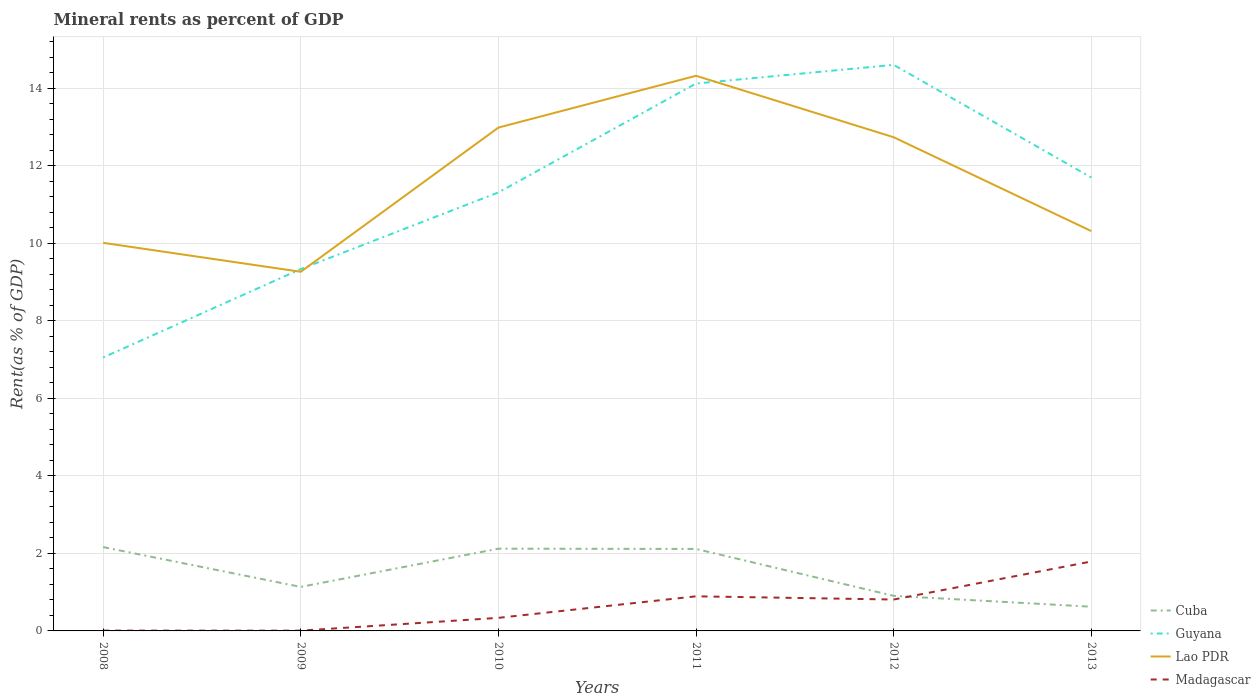How many different coloured lines are there?
Make the answer very short. 4. Is the number of lines equal to the number of legend labels?
Keep it short and to the point. Yes. Across all years, what is the maximum mineral rent in Madagascar?
Your answer should be compact. 0.01. What is the total mineral rent in Cuba in the graph?
Offer a terse response. 1.49. What is the difference between the highest and the second highest mineral rent in Guyana?
Offer a very short reply. 7.55. What is the difference between the highest and the lowest mineral rent in Cuba?
Your answer should be compact. 3. Is the mineral rent in Madagascar strictly greater than the mineral rent in Cuba over the years?
Your response must be concise. No. How many years are there in the graph?
Offer a very short reply. 6. Are the values on the major ticks of Y-axis written in scientific E-notation?
Ensure brevity in your answer.  No. Does the graph contain grids?
Provide a short and direct response. Yes. What is the title of the graph?
Your response must be concise. Mineral rents as percent of GDP. Does "Romania" appear as one of the legend labels in the graph?
Make the answer very short. No. What is the label or title of the Y-axis?
Offer a very short reply. Rent(as % of GDP). What is the Rent(as % of GDP) of Cuba in 2008?
Keep it short and to the point. 2.16. What is the Rent(as % of GDP) in Guyana in 2008?
Make the answer very short. 7.06. What is the Rent(as % of GDP) of Lao PDR in 2008?
Offer a very short reply. 10.02. What is the Rent(as % of GDP) of Madagascar in 2008?
Provide a short and direct response. 0.01. What is the Rent(as % of GDP) of Cuba in 2009?
Your answer should be compact. 1.14. What is the Rent(as % of GDP) of Guyana in 2009?
Your answer should be very brief. 9.34. What is the Rent(as % of GDP) of Lao PDR in 2009?
Your response must be concise. 9.27. What is the Rent(as % of GDP) of Madagascar in 2009?
Provide a short and direct response. 0.01. What is the Rent(as % of GDP) of Cuba in 2010?
Offer a terse response. 2.12. What is the Rent(as % of GDP) in Guyana in 2010?
Ensure brevity in your answer.  11.32. What is the Rent(as % of GDP) of Lao PDR in 2010?
Your answer should be compact. 12.99. What is the Rent(as % of GDP) of Madagascar in 2010?
Your answer should be compact. 0.34. What is the Rent(as % of GDP) in Cuba in 2011?
Give a very brief answer. 2.12. What is the Rent(as % of GDP) of Guyana in 2011?
Make the answer very short. 14.13. What is the Rent(as % of GDP) of Lao PDR in 2011?
Offer a very short reply. 14.33. What is the Rent(as % of GDP) of Madagascar in 2011?
Ensure brevity in your answer.  0.89. What is the Rent(as % of GDP) in Cuba in 2012?
Offer a very short reply. 0.91. What is the Rent(as % of GDP) of Guyana in 2012?
Keep it short and to the point. 14.61. What is the Rent(as % of GDP) in Lao PDR in 2012?
Ensure brevity in your answer.  12.74. What is the Rent(as % of GDP) in Madagascar in 2012?
Keep it short and to the point. 0.81. What is the Rent(as % of GDP) in Cuba in 2013?
Provide a short and direct response. 0.62. What is the Rent(as % of GDP) in Guyana in 2013?
Keep it short and to the point. 11.7. What is the Rent(as % of GDP) of Lao PDR in 2013?
Keep it short and to the point. 10.32. What is the Rent(as % of GDP) in Madagascar in 2013?
Provide a short and direct response. 1.79. Across all years, what is the maximum Rent(as % of GDP) in Cuba?
Keep it short and to the point. 2.16. Across all years, what is the maximum Rent(as % of GDP) in Guyana?
Provide a short and direct response. 14.61. Across all years, what is the maximum Rent(as % of GDP) of Lao PDR?
Offer a very short reply. 14.33. Across all years, what is the maximum Rent(as % of GDP) of Madagascar?
Offer a terse response. 1.79. Across all years, what is the minimum Rent(as % of GDP) of Cuba?
Make the answer very short. 0.62. Across all years, what is the minimum Rent(as % of GDP) of Guyana?
Give a very brief answer. 7.06. Across all years, what is the minimum Rent(as % of GDP) of Lao PDR?
Offer a terse response. 9.27. Across all years, what is the minimum Rent(as % of GDP) of Madagascar?
Provide a succinct answer. 0.01. What is the total Rent(as % of GDP) in Cuba in the graph?
Offer a very short reply. 9.07. What is the total Rent(as % of GDP) in Guyana in the graph?
Offer a terse response. 68.15. What is the total Rent(as % of GDP) of Lao PDR in the graph?
Ensure brevity in your answer.  69.67. What is the total Rent(as % of GDP) in Madagascar in the graph?
Ensure brevity in your answer.  3.85. What is the difference between the Rent(as % of GDP) of Cuba in 2008 and that in 2009?
Make the answer very short. 1.03. What is the difference between the Rent(as % of GDP) of Guyana in 2008 and that in 2009?
Give a very brief answer. -2.28. What is the difference between the Rent(as % of GDP) in Lao PDR in 2008 and that in 2009?
Provide a short and direct response. 0.75. What is the difference between the Rent(as % of GDP) in Madagascar in 2008 and that in 2009?
Your answer should be compact. 0. What is the difference between the Rent(as % of GDP) of Cuba in 2008 and that in 2010?
Provide a short and direct response. 0.04. What is the difference between the Rent(as % of GDP) in Guyana in 2008 and that in 2010?
Provide a short and direct response. -4.26. What is the difference between the Rent(as % of GDP) in Lao PDR in 2008 and that in 2010?
Offer a terse response. -2.97. What is the difference between the Rent(as % of GDP) of Madagascar in 2008 and that in 2010?
Ensure brevity in your answer.  -0.33. What is the difference between the Rent(as % of GDP) of Cuba in 2008 and that in 2011?
Make the answer very short. 0.05. What is the difference between the Rent(as % of GDP) of Guyana in 2008 and that in 2011?
Ensure brevity in your answer.  -7.07. What is the difference between the Rent(as % of GDP) of Lao PDR in 2008 and that in 2011?
Your answer should be very brief. -4.31. What is the difference between the Rent(as % of GDP) in Madagascar in 2008 and that in 2011?
Ensure brevity in your answer.  -0.88. What is the difference between the Rent(as % of GDP) in Cuba in 2008 and that in 2012?
Provide a succinct answer. 1.26. What is the difference between the Rent(as % of GDP) of Guyana in 2008 and that in 2012?
Provide a succinct answer. -7.55. What is the difference between the Rent(as % of GDP) in Lao PDR in 2008 and that in 2012?
Your answer should be very brief. -2.73. What is the difference between the Rent(as % of GDP) in Madagascar in 2008 and that in 2012?
Give a very brief answer. -0.8. What is the difference between the Rent(as % of GDP) in Cuba in 2008 and that in 2013?
Keep it short and to the point. 1.54. What is the difference between the Rent(as % of GDP) of Guyana in 2008 and that in 2013?
Provide a succinct answer. -4.65. What is the difference between the Rent(as % of GDP) of Lao PDR in 2008 and that in 2013?
Your answer should be very brief. -0.3. What is the difference between the Rent(as % of GDP) of Madagascar in 2008 and that in 2013?
Make the answer very short. -1.78. What is the difference between the Rent(as % of GDP) of Cuba in 2009 and that in 2010?
Provide a short and direct response. -0.99. What is the difference between the Rent(as % of GDP) of Guyana in 2009 and that in 2010?
Give a very brief answer. -1.98. What is the difference between the Rent(as % of GDP) in Lao PDR in 2009 and that in 2010?
Your response must be concise. -3.72. What is the difference between the Rent(as % of GDP) in Madagascar in 2009 and that in 2010?
Your response must be concise. -0.33. What is the difference between the Rent(as % of GDP) in Cuba in 2009 and that in 2011?
Offer a very short reply. -0.98. What is the difference between the Rent(as % of GDP) in Guyana in 2009 and that in 2011?
Provide a short and direct response. -4.79. What is the difference between the Rent(as % of GDP) in Lao PDR in 2009 and that in 2011?
Your response must be concise. -5.06. What is the difference between the Rent(as % of GDP) in Madagascar in 2009 and that in 2011?
Your answer should be compact. -0.89. What is the difference between the Rent(as % of GDP) in Cuba in 2009 and that in 2012?
Your answer should be very brief. 0.23. What is the difference between the Rent(as % of GDP) in Guyana in 2009 and that in 2012?
Ensure brevity in your answer.  -5.27. What is the difference between the Rent(as % of GDP) in Lao PDR in 2009 and that in 2012?
Provide a succinct answer. -3.47. What is the difference between the Rent(as % of GDP) of Madagascar in 2009 and that in 2012?
Your response must be concise. -0.8. What is the difference between the Rent(as % of GDP) in Cuba in 2009 and that in 2013?
Your response must be concise. 0.51. What is the difference between the Rent(as % of GDP) of Guyana in 2009 and that in 2013?
Your answer should be compact. -2.36. What is the difference between the Rent(as % of GDP) in Lao PDR in 2009 and that in 2013?
Your response must be concise. -1.05. What is the difference between the Rent(as % of GDP) of Madagascar in 2009 and that in 2013?
Provide a short and direct response. -1.78. What is the difference between the Rent(as % of GDP) in Cuba in 2010 and that in 2011?
Give a very brief answer. 0.01. What is the difference between the Rent(as % of GDP) in Guyana in 2010 and that in 2011?
Ensure brevity in your answer.  -2.81. What is the difference between the Rent(as % of GDP) of Lao PDR in 2010 and that in 2011?
Your answer should be compact. -1.34. What is the difference between the Rent(as % of GDP) in Madagascar in 2010 and that in 2011?
Give a very brief answer. -0.56. What is the difference between the Rent(as % of GDP) of Cuba in 2010 and that in 2012?
Your answer should be compact. 1.22. What is the difference between the Rent(as % of GDP) in Guyana in 2010 and that in 2012?
Offer a very short reply. -3.29. What is the difference between the Rent(as % of GDP) in Lao PDR in 2010 and that in 2012?
Keep it short and to the point. 0.25. What is the difference between the Rent(as % of GDP) of Madagascar in 2010 and that in 2012?
Ensure brevity in your answer.  -0.47. What is the difference between the Rent(as % of GDP) of Cuba in 2010 and that in 2013?
Your answer should be very brief. 1.5. What is the difference between the Rent(as % of GDP) of Guyana in 2010 and that in 2013?
Provide a short and direct response. -0.39. What is the difference between the Rent(as % of GDP) in Lao PDR in 2010 and that in 2013?
Offer a terse response. 2.67. What is the difference between the Rent(as % of GDP) of Madagascar in 2010 and that in 2013?
Make the answer very short. -1.45. What is the difference between the Rent(as % of GDP) in Cuba in 2011 and that in 2012?
Your answer should be compact. 1.21. What is the difference between the Rent(as % of GDP) of Guyana in 2011 and that in 2012?
Your answer should be compact. -0.48. What is the difference between the Rent(as % of GDP) in Lao PDR in 2011 and that in 2012?
Your answer should be compact. 1.59. What is the difference between the Rent(as % of GDP) of Madagascar in 2011 and that in 2012?
Your answer should be compact. 0.08. What is the difference between the Rent(as % of GDP) of Cuba in 2011 and that in 2013?
Make the answer very short. 1.49. What is the difference between the Rent(as % of GDP) in Guyana in 2011 and that in 2013?
Make the answer very short. 2.42. What is the difference between the Rent(as % of GDP) in Lao PDR in 2011 and that in 2013?
Ensure brevity in your answer.  4.01. What is the difference between the Rent(as % of GDP) in Madagascar in 2011 and that in 2013?
Provide a short and direct response. -0.9. What is the difference between the Rent(as % of GDP) of Cuba in 2012 and that in 2013?
Provide a succinct answer. 0.28. What is the difference between the Rent(as % of GDP) of Guyana in 2012 and that in 2013?
Your response must be concise. 2.91. What is the difference between the Rent(as % of GDP) in Lao PDR in 2012 and that in 2013?
Your response must be concise. 2.42. What is the difference between the Rent(as % of GDP) of Madagascar in 2012 and that in 2013?
Your answer should be compact. -0.98. What is the difference between the Rent(as % of GDP) in Cuba in 2008 and the Rent(as % of GDP) in Guyana in 2009?
Your response must be concise. -7.18. What is the difference between the Rent(as % of GDP) in Cuba in 2008 and the Rent(as % of GDP) in Lao PDR in 2009?
Offer a terse response. -7.11. What is the difference between the Rent(as % of GDP) of Cuba in 2008 and the Rent(as % of GDP) of Madagascar in 2009?
Your answer should be very brief. 2.16. What is the difference between the Rent(as % of GDP) of Guyana in 2008 and the Rent(as % of GDP) of Lao PDR in 2009?
Offer a very short reply. -2.21. What is the difference between the Rent(as % of GDP) of Guyana in 2008 and the Rent(as % of GDP) of Madagascar in 2009?
Your answer should be very brief. 7.05. What is the difference between the Rent(as % of GDP) in Lao PDR in 2008 and the Rent(as % of GDP) in Madagascar in 2009?
Your response must be concise. 10.01. What is the difference between the Rent(as % of GDP) in Cuba in 2008 and the Rent(as % of GDP) in Guyana in 2010?
Offer a terse response. -9.15. What is the difference between the Rent(as % of GDP) of Cuba in 2008 and the Rent(as % of GDP) of Lao PDR in 2010?
Offer a very short reply. -10.83. What is the difference between the Rent(as % of GDP) in Cuba in 2008 and the Rent(as % of GDP) in Madagascar in 2010?
Offer a terse response. 1.83. What is the difference between the Rent(as % of GDP) of Guyana in 2008 and the Rent(as % of GDP) of Lao PDR in 2010?
Provide a short and direct response. -5.93. What is the difference between the Rent(as % of GDP) in Guyana in 2008 and the Rent(as % of GDP) in Madagascar in 2010?
Give a very brief answer. 6.72. What is the difference between the Rent(as % of GDP) in Lao PDR in 2008 and the Rent(as % of GDP) in Madagascar in 2010?
Your answer should be compact. 9.68. What is the difference between the Rent(as % of GDP) in Cuba in 2008 and the Rent(as % of GDP) in Guyana in 2011?
Provide a short and direct response. -11.96. What is the difference between the Rent(as % of GDP) of Cuba in 2008 and the Rent(as % of GDP) of Lao PDR in 2011?
Give a very brief answer. -12.16. What is the difference between the Rent(as % of GDP) of Cuba in 2008 and the Rent(as % of GDP) of Madagascar in 2011?
Provide a short and direct response. 1.27. What is the difference between the Rent(as % of GDP) in Guyana in 2008 and the Rent(as % of GDP) in Lao PDR in 2011?
Offer a terse response. -7.27. What is the difference between the Rent(as % of GDP) of Guyana in 2008 and the Rent(as % of GDP) of Madagascar in 2011?
Your answer should be compact. 6.16. What is the difference between the Rent(as % of GDP) of Lao PDR in 2008 and the Rent(as % of GDP) of Madagascar in 2011?
Give a very brief answer. 9.12. What is the difference between the Rent(as % of GDP) in Cuba in 2008 and the Rent(as % of GDP) in Guyana in 2012?
Your response must be concise. -12.45. What is the difference between the Rent(as % of GDP) in Cuba in 2008 and the Rent(as % of GDP) in Lao PDR in 2012?
Your response must be concise. -10.58. What is the difference between the Rent(as % of GDP) in Cuba in 2008 and the Rent(as % of GDP) in Madagascar in 2012?
Offer a terse response. 1.35. What is the difference between the Rent(as % of GDP) in Guyana in 2008 and the Rent(as % of GDP) in Lao PDR in 2012?
Your answer should be compact. -5.69. What is the difference between the Rent(as % of GDP) in Guyana in 2008 and the Rent(as % of GDP) in Madagascar in 2012?
Provide a succinct answer. 6.25. What is the difference between the Rent(as % of GDP) in Lao PDR in 2008 and the Rent(as % of GDP) in Madagascar in 2012?
Provide a succinct answer. 9.21. What is the difference between the Rent(as % of GDP) of Cuba in 2008 and the Rent(as % of GDP) of Guyana in 2013?
Your answer should be compact. -9.54. What is the difference between the Rent(as % of GDP) of Cuba in 2008 and the Rent(as % of GDP) of Lao PDR in 2013?
Keep it short and to the point. -8.16. What is the difference between the Rent(as % of GDP) of Cuba in 2008 and the Rent(as % of GDP) of Madagascar in 2013?
Offer a terse response. 0.37. What is the difference between the Rent(as % of GDP) in Guyana in 2008 and the Rent(as % of GDP) in Lao PDR in 2013?
Offer a terse response. -3.26. What is the difference between the Rent(as % of GDP) in Guyana in 2008 and the Rent(as % of GDP) in Madagascar in 2013?
Your response must be concise. 5.26. What is the difference between the Rent(as % of GDP) in Lao PDR in 2008 and the Rent(as % of GDP) in Madagascar in 2013?
Give a very brief answer. 8.23. What is the difference between the Rent(as % of GDP) in Cuba in 2009 and the Rent(as % of GDP) in Guyana in 2010?
Give a very brief answer. -10.18. What is the difference between the Rent(as % of GDP) of Cuba in 2009 and the Rent(as % of GDP) of Lao PDR in 2010?
Make the answer very short. -11.85. What is the difference between the Rent(as % of GDP) of Cuba in 2009 and the Rent(as % of GDP) of Madagascar in 2010?
Offer a very short reply. 0.8. What is the difference between the Rent(as % of GDP) in Guyana in 2009 and the Rent(as % of GDP) in Lao PDR in 2010?
Make the answer very short. -3.65. What is the difference between the Rent(as % of GDP) of Guyana in 2009 and the Rent(as % of GDP) of Madagascar in 2010?
Offer a terse response. 9. What is the difference between the Rent(as % of GDP) in Lao PDR in 2009 and the Rent(as % of GDP) in Madagascar in 2010?
Your response must be concise. 8.93. What is the difference between the Rent(as % of GDP) in Cuba in 2009 and the Rent(as % of GDP) in Guyana in 2011?
Your response must be concise. -12.99. What is the difference between the Rent(as % of GDP) in Cuba in 2009 and the Rent(as % of GDP) in Lao PDR in 2011?
Your answer should be compact. -13.19. What is the difference between the Rent(as % of GDP) in Cuba in 2009 and the Rent(as % of GDP) in Madagascar in 2011?
Give a very brief answer. 0.24. What is the difference between the Rent(as % of GDP) in Guyana in 2009 and the Rent(as % of GDP) in Lao PDR in 2011?
Provide a short and direct response. -4.99. What is the difference between the Rent(as % of GDP) of Guyana in 2009 and the Rent(as % of GDP) of Madagascar in 2011?
Ensure brevity in your answer.  8.45. What is the difference between the Rent(as % of GDP) in Lao PDR in 2009 and the Rent(as % of GDP) in Madagascar in 2011?
Offer a very short reply. 8.38. What is the difference between the Rent(as % of GDP) of Cuba in 2009 and the Rent(as % of GDP) of Guyana in 2012?
Provide a succinct answer. -13.47. What is the difference between the Rent(as % of GDP) of Cuba in 2009 and the Rent(as % of GDP) of Lao PDR in 2012?
Offer a very short reply. -11.61. What is the difference between the Rent(as % of GDP) of Cuba in 2009 and the Rent(as % of GDP) of Madagascar in 2012?
Provide a succinct answer. 0.33. What is the difference between the Rent(as % of GDP) in Guyana in 2009 and the Rent(as % of GDP) in Lao PDR in 2012?
Offer a very short reply. -3.4. What is the difference between the Rent(as % of GDP) of Guyana in 2009 and the Rent(as % of GDP) of Madagascar in 2012?
Ensure brevity in your answer.  8.53. What is the difference between the Rent(as % of GDP) of Lao PDR in 2009 and the Rent(as % of GDP) of Madagascar in 2012?
Ensure brevity in your answer.  8.46. What is the difference between the Rent(as % of GDP) of Cuba in 2009 and the Rent(as % of GDP) of Guyana in 2013?
Ensure brevity in your answer.  -10.57. What is the difference between the Rent(as % of GDP) of Cuba in 2009 and the Rent(as % of GDP) of Lao PDR in 2013?
Make the answer very short. -9.18. What is the difference between the Rent(as % of GDP) of Cuba in 2009 and the Rent(as % of GDP) of Madagascar in 2013?
Your answer should be compact. -0.66. What is the difference between the Rent(as % of GDP) of Guyana in 2009 and the Rent(as % of GDP) of Lao PDR in 2013?
Your answer should be compact. -0.98. What is the difference between the Rent(as % of GDP) of Guyana in 2009 and the Rent(as % of GDP) of Madagascar in 2013?
Make the answer very short. 7.55. What is the difference between the Rent(as % of GDP) of Lao PDR in 2009 and the Rent(as % of GDP) of Madagascar in 2013?
Your answer should be compact. 7.48. What is the difference between the Rent(as % of GDP) in Cuba in 2010 and the Rent(as % of GDP) in Guyana in 2011?
Provide a succinct answer. -12.01. What is the difference between the Rent(as % of GDP) of Cuba in 2010 and the Rent(as % of GDP) of Lao PDR in 2011?
Provide a short and direct response. -12.21. What is the difference between the Rent(as % of GDP) of Cuba in 2010 and the Rent(as % of GDP) of Madagascar in 2011?
Give a very brief answer. 1.23. What is the difference between the Rent(as % of GDP) in Guyana in 2010 and the Rent(as % of GDP) in Lao PDR in 2011?
Keep it short and to the point. -3.01. What is the difference between the Rent(as % of GDP) in Guyana in 2010 and the Rent(as % of GDP) in Madagascar in 2011?
Provide a succinct answer. 10.42. What is the difference between the Rent(as % of GDP) in Lao PDR in 2010 and the Rent(as % of GDP) in Madagascar in 2011?
Offer a very short reply. 12.1. What is the difference between the Rent(as % of GDP) in Cuba in 2010 and the Rent(as % of GDP) in Guyana in 2012?
Make the answer very short. -12.49. What is the difference between the Rent(as % of GDP) of Cuba in 2010 and the Rent(as % of GDP) of Lao PDR in 2012?
Your answer should be very brief. -10.62. What is the difference between the Rent(as % of GDP) of Cuba in 2010 and the Rent(as % of GDP) of Madagascar in 2012?
Provide a short and direct response. 1.31. What is the difference between the Rent(as % of GDP) of Guyana in 2010 and the Rent(as % of GDP) of Lao PDR in 2012?
Your response must be concise. -1.42. What is the difference between the Rent(as % of GDP) of Guyana in 2010 and the Rent(as % of GDP) of Madagascar in 2012?
Your answer should be compact. 10.51. What is the difference between the Rent(as % of GDP) of Lao PDR in 2010 and the Rent(as % of GDP) of Madagascar in 2012?
Your response must be concise. 12.18. What is the difference between the Rent(as % of GDP) in Cuba in 2010 and the Rent(as % of GDP) in Guyana in 2013?
Your answer should be very brief. -9.58. What is the difference between the Rent(as % of GDP) of Cuba in 2010 and the Rent(as % of GDP) of Lao PDR in 2013?
Offer a terse response. -8.2. What is the difference between the Rent(as % of GDP) of Cuba in 2010 and the Rent(as % of GDP) of Madagascar in 2013?
Ensure brevity in your answer.  0.33. What is the difference between the Rent(as % of GDP) of Guyana in 2010 and the Rent(as % of GDP) of Lao PDR in 2013?
Your answer should be very brief. 1. What is the difference between the Rent(as % of GDP) of Guyana in 2010 and the Rent(as % of GDP) of Madagascar in 2013?
Offer a very short reply. 9.53. What is the difference between the Rent(as % of GDP) in Lao PDR in 2010 and the Rent(as % of GDP) in Madagascar in 2013?
Provide a short and direct response. 11.2. What is the difference between the Rent(as % of GDP) in Cuba in 2011 and the Rent(as % of GDP) in Guyana in 2012?
Ensure brevity in your answer.  -12.49. What is the difference between the Rent(as % of GDP) of Cuba in 2011 and the Rent(as % of GDP) of Lao PDR in 2012?
Ensure brevity in your answer.  -10.63. What is the difference between the Rent(as % of GDP) of Cuba in 2011 and the Rent(as % of GDP) of Madagascar in 2012?
Your response must be concise. 1.31. What is the difference between the Rent(as % of GDP) of Guyana in 2011 and the Rent(as % of GDP) of Lao PDR in 2012?
Provide a short and direct response. 1.39. What is the difference between the Rent(as % of GDP) in Guyana in 2011 and the Rent(as % of GDP) in Madagascar in 2012?
Give a very brief answer. 13.32. What is the difference between the Rent(as % of GDP) of Lao PDR in 2011 and the Rent(as % of GDP) of Madagascar in 2012?
Provide a short and direct response. 13.52. What is the difference between the Rent(as % of GDP) of Cuba in 2011 and the Rent(as % of GDP) of Guyana in 2013?
Your answer should be very brief. -9.59. What is the difference between the Rent(as % of GDP) of Cuba in 2011 and the Rent(as % of GDP) of Lao PDR in 2013?
Ensure brevity in your answer.  -8.2. What is the difference between the Rent(as % of GDP) in Cuba in 2011 and the Rent(as % of GDP) in Madagascar in 2013?
Your response must be concise. 0.32. What is the difference between the Rent(as % of GDP) in Guyana in 2011 and the Rent(as % of GDP) in Lao PDR in 2013?
Your answer should be very brief. 3.81. What is the difference between the Rent(as % of GDP) of Guyana in 2011 and the Rent(as % of GDP) of Madagascar in 2013?
Your answer should be very brief. 12.34. What is the difference between the Rent(as % of GDP) in Lao PDR in 2011 and the Rent(as % of GDP) in Madagascar in 2013?
Make the answer very short. 12.54. What is the difference between the Rent(as % of GDP) in Cuba in 2012 and the Rent(as % of GDP) in Guyana in 2013?
Offer a very short reply. -10.8. What is the difference between the Rent(as % of GDP) of Cuba in 2012 and the Rent(as % of GDP) of Lao PDR in 2013?
Provide a short and direct response. -9.41. What is the difference between the Rent(as % of GDP) in Cuba in 2012 and the Rent(as % of GDP) in Madagascar in 2013?
Give a very brief answer. -0.89. What is the difference between the Rent(as % of GDP) in Guyana in 2012 and the Rent(as % of GDP) in Lao PDR in 2013?
Your response must be concise. 4.29. What is the difference between the Rent(as % of GDP) in Guyana in 2012 and the Rent(as % of GDP) in Madagascar in 2013?
Offer a terse response. 12.82. What is the difference between the Rent(as % of GDP) of Lao PDR in 2012 and the Rent(as % of GDP) of Madagascar in 2013?
Give a very brief answer. 10.95. What is the average Rent(as % of GDP) in Cuba per year?
Ensure brevity in your answer.  1.51. What is the average Rent(as % of GDP) in Guyana per year?
Provide a short and direct response. 11.36. What is the average Rent(as % of GDP) in Lao PDR per year?
Offer a very short reply. 11.61. What is the average Rent(as % of GDP) of Madagascar per year?
Your answer should be very brief. 0.64. In the year 2008, what is the difference between the Rent(as % of GDP) in Cuba and Rent(as % of GDP) in Guyana?
Offer a terse response. -4.89. In the year 2008, what is the difference between the Rent(as % of GDP) of Cuba and Rent(as % of GDP) of Lao PDR?
Offer a terse response. -7.85. In the year 2008, what is the difference between the Rent(as % of GDP) of Cuba and Rent(as % of GDP) of Madagascar?
Provide a short and direct response. 2.16. In the year 2008, what is the difference between the Rent(as % of GDP) in Guyana and Rent(as % of GDP) in Lao PDR?
Ensure brevity in your answer.  -2.96. In the year 2008, what is the difference between the Rent(as % of GDP) of Guyana and Rent(as % of GDP) of Madagascar?
Provide a succinct answer. 7.05. In the year 2008, what is the difference between the Rent(as % of GDP) in Lao PDR and Rent(as % of GDP) in Madagascar?
Provide a succinct answer. 10.01. In the year 2009, what is the difference between the Rent(as % of GDP) of Cuba and Rent(as % of GDP) of Guyana?
Ensure brevity in your answer.  -8.2. In the year 2009, what is the difference between the Rent(as % of GDP) of Cuba and Rent(as % of GDP) of Lao PDR?
Offer a very short reply. -8.13. In the year 2009, what is the difference between the Rent(as % of GDP) of Cuba and Rent(as % of GDP) of Madagascar?
Offer a terse response. 1.13. In the year 2009, what is the difference between the Rent(as % of GDP) of Guyana and Rent(as % of GDP) of Lao PDR?
Your answer should be compact. 0.07. In the year 2009, what is the difference between the Rent(as % of GDP) in Guyana and Rent(as % of GDP) in Madagascar?
Your answer should be compact. 9.33. In the year 2009, what is the difference between the Rent(as % of GDP) in Lao PDR and Rent(as % of GDP) in Madagascar?
Ensure brevity in your answer.  9.26. In the year 2010, what is the difference between the Rent(as % of GDP) of Cuba and Rent(as % of GDP) of Guyana?
Provide a short and direct response. -9.2. In the year 2010, what is the difference between the Rent(as % of GDP) of Cuba and Rent(as % of GDP) of Lao PDR?
Provide a succinct answer. -10.87. In the year 2010, what is the difference between the Rent(as % of GDP) of Cuba and Rent(as % of GDP) of Madagascar?
Keep it short and to the point. 1.78. In the year 2010, what is the difference between the Rent(as % of GDP) in Guyana and Rent(as % of GDP) in Lao PDR?
Your answer should be very brief. -1.67. In the year 2010, what is the difference between the Rent(as % of GDP) in Guyana and Rent(as % of GDP) in Madagascar?
Offer a terse response. 10.98. In the year 2010, what is the difference between the Rent(as % of GDP) of Lao PDR and Rent(as % of GDP) of Madagascar?
Your answer should be compact. 12.65. In the year 2011, what is the difference between the Rent(as % of GDP) in Cuba and Rent(as % of GDP) in Guyana?
Offer a terse response. -12.01. In the year 2011, what is the difference between the Rent(as % of GDP) in Cuba and Rent(as % of GDP) in Lao PDR?
Provide a short and direct response. -12.21. In the year 2011, what is the difference between the Rent(as % of GDP) in Cuba and Rent(as % of GDP) in Madagascar?
Keep it short and to the point. 1.22. In the year 2011, what is the difference between the Rent(as % of GDP) in Guyana and Rent(as % of GDP) in Lao PDR?
Offer a very short reply. -0.2. In the year 2011, what is the difference between the Rent(as % of GDP) of Guyana and Rent(as % of GDP) of Madagascar?
Offer a terse response. 13.23. In the year 2011, what is the difference between the Rent(as % of GDP) of Lao PDR and Rent(as % of GDP) of Madagascar?
Ensure brevity in your answer.  13.43. In the year 2012, what is the difference between the Rent(as % of GDP) of Cuba and Rent(as % of GDP) of Guyana?
Your answer should be very brief. -13.7. In the year 2012, what is the difference between the Rent(as % of GDP) in Cuba and Rent(as % of GDP) in Lao PDR?
Offer a very short reply. -11.84. In the year 2012, what is the difference between the Rent(as % of GDP) of Cuba and Rent(as % of GDP) of Madagascar?
Offer a terse response. 0.09. In the year 2012, what is the difference between the Rent(as % of GDP) of Guyana and Rent(as % of GDP) of Lao PDR?
Ensure brevity in your answer.  1.87. In the year 2012, what is the difference between the Rent(as % of GDP) of Guyana and Rent(as % of GDP) of Madagascar?
Your response must be concise. 13.8. In the year 2012, what is the difference between the Rent(as % of GDP) of Lao PDR and Rent(as % of GDP) of Madagascar?
Provide a succinct answer. 11.93. In the year 2013, what is the difference between the Rent(as % of GDP) in Cuba and Rent(as % of GDP) in Guyana?
Provide a short and direct response. -11.08. In the year 2013, what is the difference between the Rent(as % of GDP) of Cuba and Rent(as % of GDP) of Lao PDR?
Give a very brief answer. -9.69. In the year 2013, what is the difference between the Rent(as % of GDP) in Cuba and Rent(as % of GDP) in Madagascar?
Your answer should be very brief. -1.17. In the year 2013, what is the difference between the Rent(as % of GDP) of Guyana and Rent(as % of GDP) of Lao PDR?
Your answer should be very brief. 1.38. In the year 2013, what is the difference between the Rent(as % of GDP) of Guyana and Rent(as % of GDP) of Madagascar?
Ensure brevity in your answer.  9.91. In the year 2013, what is the difference between the Rent(as % of GDP) of Lao PDR and Rent(as % of GDP) of Madagascar?
Your answer should be compact. 8.53. What is the ratio of the Rent(as % of GDP) in Cuba in 2008 to that in 2009?
Offer a very short reply. 1.9. What is the ratio of the Rent(as % of GDP) in Guyana in 2008 to that in 2009?
Offer a very short reply. 0.76. What is the ratio of the Rent(as % of GDP) of Lao PDR in 2008 to that in 2009?
Your answer should be very brief. 1.08. What is the ratio of the Rent(as % of GDP) of Madagascar in 2008 to that in 2009?
Your answer should be compact. 1.16. What is the ratio of the Rent(as % of GDP) of Cuba in 2008 to that in 2010?
Ensure brevity in your answer.  1.02. What is the ratio of the Rent(as % of GDP) in Guyana in 2008 to that in 2010?
Give a very brief answer. 0.62. What is the ratio of the Rent(as % of GDP) of Lao PDR in 2008 to that in 2010?
Ensure brevity in your answer.  0.77. What is the ratio of the Rent(as % of GDP) in Madagascar in 2008 to that in 2010?
Your answer should be compact. 0.02. What is the ratio of the Rent(as % of GDP) in Cuba in 2008 to that in 2011?
Offer a very short reply. 1.02. What is the ratio of the Rent(as % of GDP) of Guyana in 2008 to that in 2011?
Provide a short and direct response. 0.5. What is the ratio of the Rent(as % of GDP) in Lao PDR in 2008 to that in 2011?
Provide a succinct answer. 0.7. What is the ratio of the Rent(as % of GDP) in Madagascar in 2008 to that in 2011?
Your response must be concise. 0.01. What is the ratio of the Rent(as % of GDP) in Cuba in 2008 to that in 2012?
Offer a very short reply. 2.39. What is the ratio of the Rent(as % of GDP) in Guyana in 2008 to that in 2012?
Ensure brevity in your answer.  0.48. What is the ratio of the Rent(as % of GDP) of Lao PDR in 2008 to that in 2012?
Your answer should be compact. 0.79. What is the ratio of the Rent(as % of GDP) of Madagascar in 2008 to that in 2012?
Ensure brevity in your answer.  0.01. What is the ratio of the Rent(as % of GDP) in Cuba in 2008 to that in 2013?
Offer a terse response. 3.46. What is the ratio of the Rent(as % of GDP) in Guyana in 2008 to that in 2013?
Offer a terse response. 0.6. What is the ratio of the Rent(as % of GDP) in Lao PDR in 2008 to that in 2013?
Offer a terse response. 0.97. What is the ratio of the Rent(as % of GDP) of Madagascar in 2008 to that in 2013?
Offer a very short reply. 0. What is the ratio of the Rent(as % of GDP) of Cuba in 2009 to that in 2010?
Keep it short and to the point. 0.54. What is the ratio of the Rent(as % of GDP) in Guyana in 2009 to that in 2010?
Offer a terse response. 0.83. What is the ratio of the Rent(as % of GDP) of Lao PDR in 2009 to that in 2010?
Offer a terse response. 0.71. What is the ratio of the Rent(as % of GDP) of Madagascar in 2009 to that in 2010?
Ensure brevity in your answer.  0.02. What is the ratio of the Rent(as % of GDP) in Cuba in 2009 to that in 2011?
Offer a terse response. 0.54. What is the ratio of the Rent(as % of GDP) of Guyana in 2009 to that in 2011?
Your answer should be compact. 0.66. What is the ratio of the Rent(as % of GDP) in Lao PDR in 2009 to that in 2011?
Keep it short and to the point. 0.65. What is the ratio of the Rent(as % of GDP) in Madagascar in 2009 to that in 2011?
Offer a very short reply. 0.01. What is the ratio of the Rent(as % of GDP) in Cuba in 2009 to that in 2012?
Your answer should be compact. 1.26. What is the ratio of the Rent(as % of GDP) in Guyana in 2009 to that in 2012?
Offer a very short reply. 0.64. What is the ratio of the Rent(as % of GDP) in Lao PDR in 2009 to that in 2012?
Provide a succinct answer. 0.73. What is the ratio of the Rent(as % of GDP) in Madagascar in 2009 to that in 2012?
Your answer should be compact. 0.01. What is the ratio of the Rent(as % of GDP) of Cuba in 2009 to that in 2013?
Keep it short and to the point. 1.82. What is the ratio of the Rent(as % of GDP) of Guyana in 2009 to that in 2013?
Keep it short and to the point. 0.8. What is the ratio of the Rent(as % of GDP) of Lao PDR in 2009 to that in 2013?
Provide a short and direct response. 0.9. What is the ratio of the Rent(as % of GDP) in Madagascar in 2009 to that in 2013?
Make the answer very short. 0. What is the ratio of the Rent(as % of GDP) in Guyana in 2010 to that in 2011?
Provide a succinct answer. 0.8. What is the ratio of the Rent(as % of GDP) of Lao PDR in 2010 to that in 2011?
Your answer should be compact. 0.91. What is the ratio of the Rent(as % of GDP) in Madagascar in 2010 to that in 2011?
Your answer should be very brief. 0.38. What is the ratio of the Rent(as % of GDP) in Cuba in 2010 to that in 2012?
Your response must be concise. 2.34. What is the ratio of the Rent(as % of GDP) in Guyana in 2010 to that in 2012?
Provide a succinct answer. 0.77. What is the ratio of the Rent(as % of GDP) of Lao PDR in 2010 to that in 2012?
Your answer should be compact. 1.02. What is the ratio of the Rent(as % of GDP) of Madagascar in 2010 to that in 2012?
Provide a short and direct response. 0.42. What is the ratio of the Rent(as % of GDP) of Cuba in 2010 to that in 2013?
Offer a terse response. 3.4. What is the ratio of the Rent(as % of GDP) in Guyana in 2010 to that in 2013?
Make the answer very short. 0.97. What is the ratio of the Rent(as % of GDP) in Lao PDR in 2010 to that in 2013?
Ensure brevity in your answer.  1.26. What is the ratio of the Rent(as % of GDP) of Madagascar in 2010 to that in 2013?
Your answer should be very brief. 0.19. What is the ratio of the Rent(as % of GDP) of Cuba in 2011 to that in 2012?
Give a very brief answer. 2.34. What is the ratio of the Rent(as % of GDP) of Guyana in 2011 to that in 2012?
Provide a short and direct response. 0.97. What is the ratio of the Rent(as % of GDP) of Lao PDR in 2011 to that in 2012?
Offer a very short reply. 1.12. What is the ratio of the Rent(as % of GDP) of Madagascar in 2011 to that in 2012?
Give a very brief answer. 1.1. What is the ratio of the Rent(as % of GDP) of Cuba in 2011 to that in 2013?
Offer a terse response. 3.39. What is the ratio of the Rent(as % of GDP) of Guyana in 2011 to that in 2013?
Provide a succinct answer. 1.21. What is the ratio of the Rent(as % of GDP) in Lao PDR in 2011 to that in 2013?
Offer a very short reply. 1.39. What is the ratio of the Rent(as % of GDP) in Madagascar in 2011 to that in 2013?
Offer a very short reply. 0.5. What is the ratio of the Rent(as % of GDP) of Cuba in 2012 to that in 2013?
Your answer should be very brief. 1.45. What is the ratio of the Rent(as % of GDP) of Guyana in 2012 to that in 2013?
Your answer should be compact. 1.25. What is the ratio of the Rent(as % of GDP) in Lao PDR in 2012 to that in 2013?
Provide a short and direct response. 1.23. What is the ratio of the Rent(as % of GDP) of Madagascar in 2012 to that in 2013?
Make the answer very short. 0.45. What is the difference between the highest and the second highest Rent(as % of GDP) of Cuba?
Make the answer very short. 0.04. What is the difference between the highest and the second highest Rent(as % of GDP) of Guyana?
Offer a terse response. 0.48. What is the difference between the highest and the second highest Rent(as % of GDP) in Lao PDR?
Give a very brief answer. 1.34. What is the difference between the highest and the second highest Rent(as % of GDP) of Madagascar?
Your response must be concise. 0.9. What is the difference between the highest and the lowest Rent(as % of GDP) of Cuba?
Your answer should be very brief. 1.54. What is the difference between the highest and the lowest Rent(as % of GDP) of Guyana?
Provide a succinct answer. 7.55. What is the difference between the highest and the lowest Rent(as % of GDP) of Lao PDR?
Give a very brief answer. 5.06. What is the difference between the highest and the lowest Rent(as % of GDP) of Madagascar?
Make the answer very short. 1.78. 